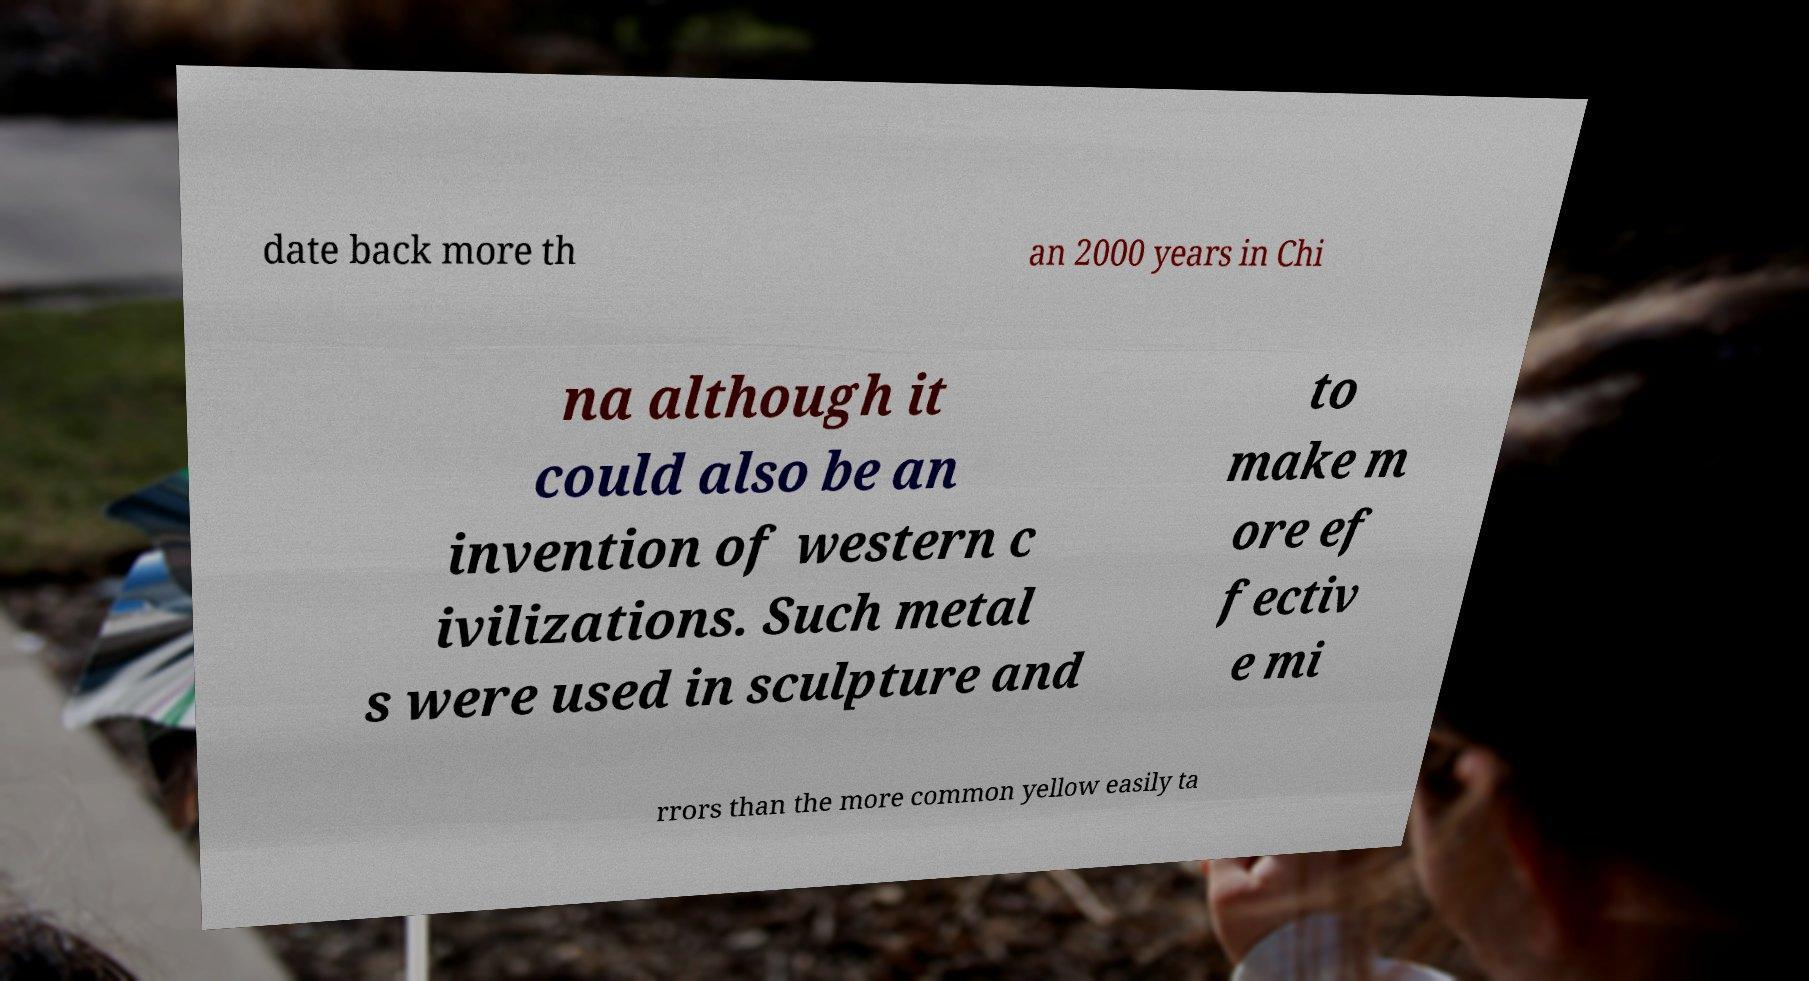Can you accurately transcribe the text from the provided image for me? date back more th an 2000 years in Chi na although it could also be an invention of western c ivilizations. Such metal s were used in sculpture and to make m ore ef fectiv e mi rrors than the more common yellow easily ta 